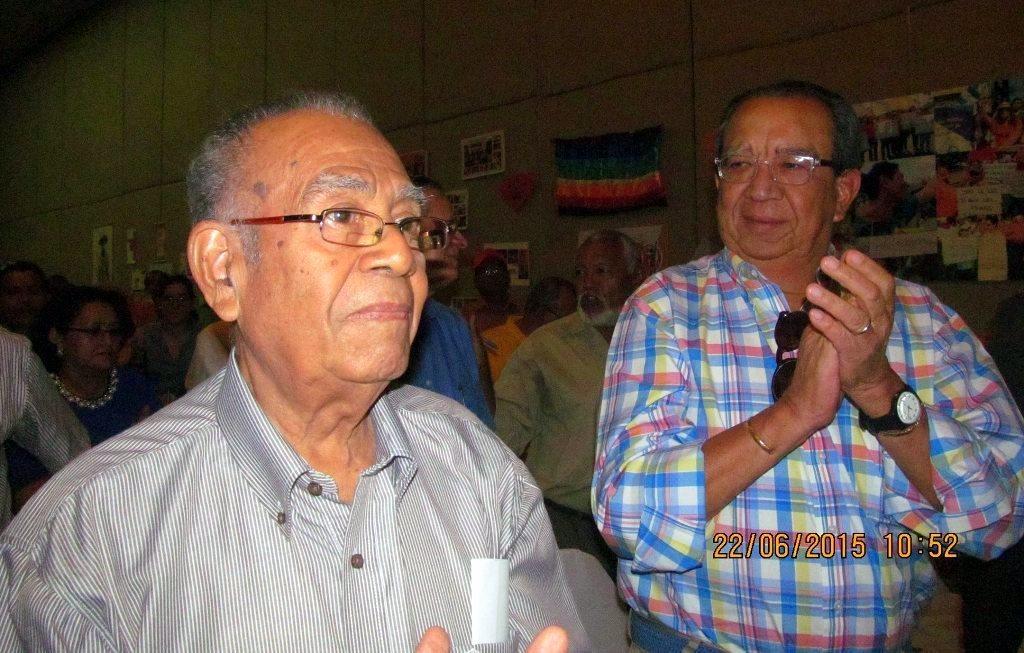Can you describe this image briefly? In this image, we can see a two men standing. In the background, we can see a group of people. On the right side, we can see few posts, flags and a photo frame attached to a wall. 